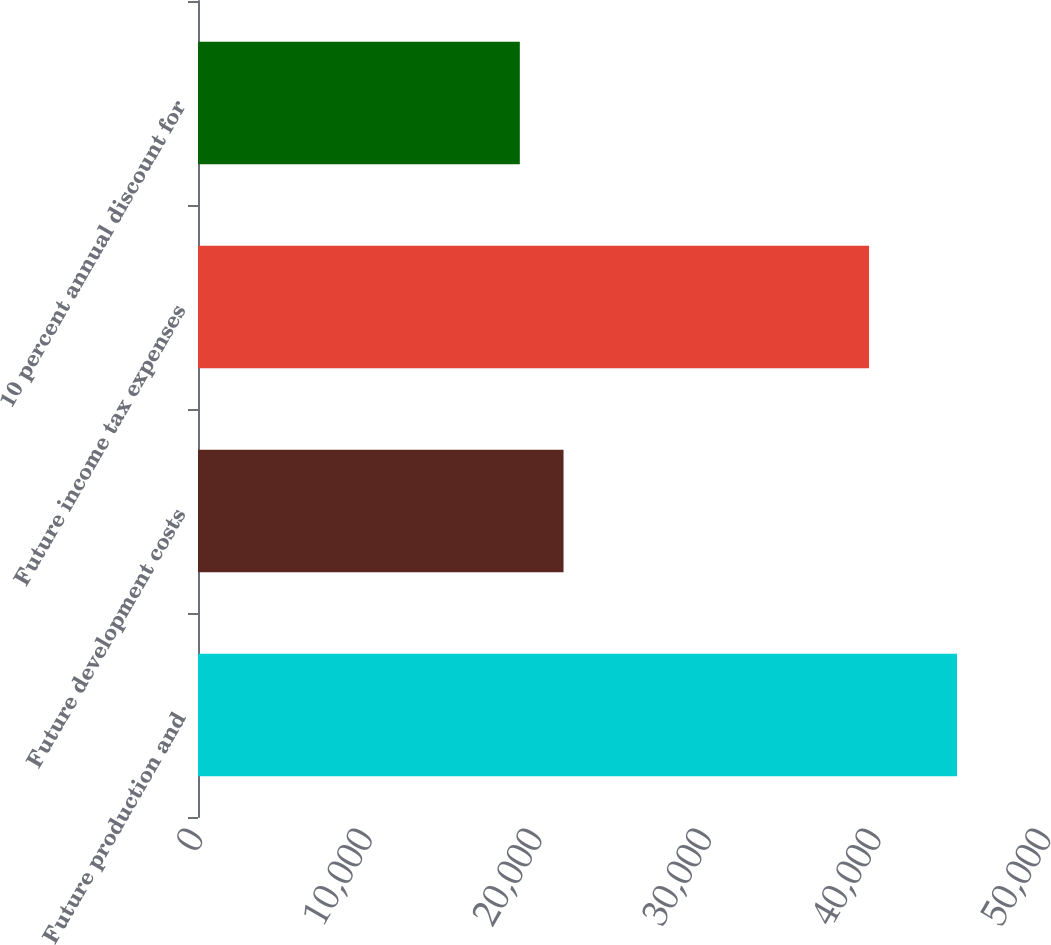<chart> <loc_0><loc_0><loc_500><loc_500><bar_chart><fcel>Future production and<fcel>Future development costs<fcel>Future income tax expenses<fcel>10 percent annual discount for<nl><fcel>44751<fcel>21552.6<fcel>39566<fcel>18975<nl></chart> 